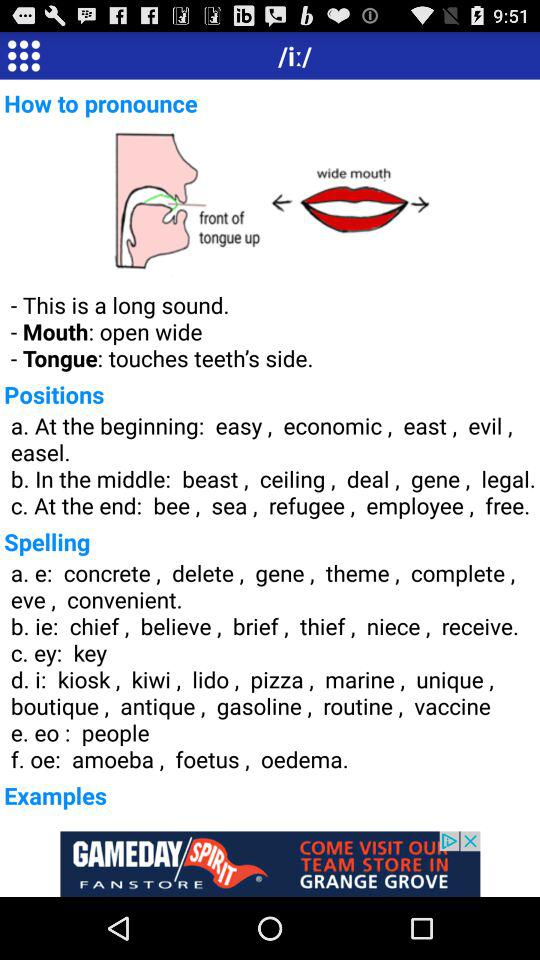How many spelling examples are there?
Answer the question using a single word or phrase. 6 